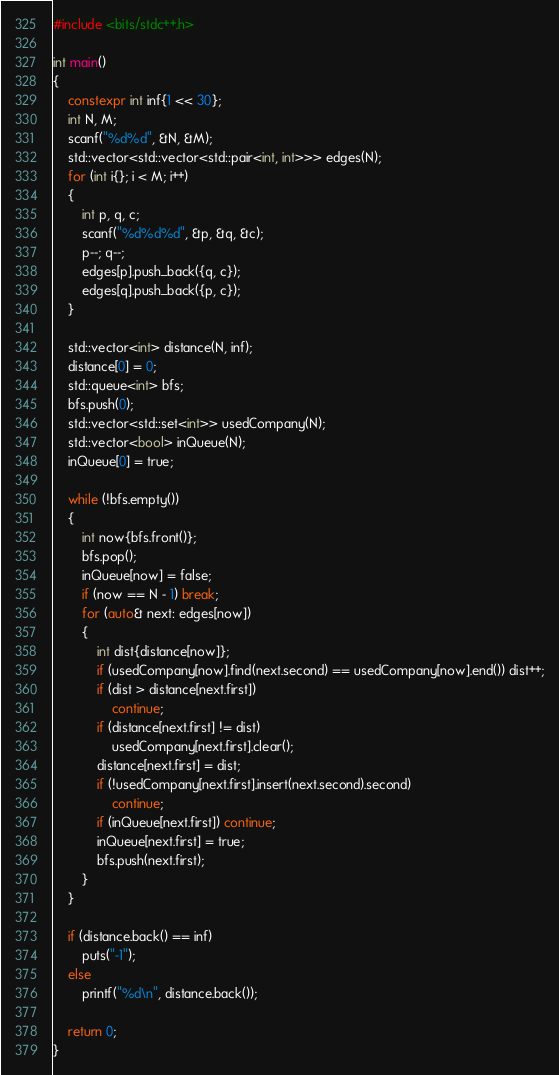Convert code to text. <code><loc_0><loc_0><loc_500><loc_500><_C++_>#include <bits/stdc++.h>

int main()
{
	constexpr int inf{1 << 30};
	int N, M;
	scanf("%d%d", &N, &M);
	std::vector<std::vector<std::pair<int, int>>> edges(N);
	for (int i{}; i < M; i++)
	{
		int p, q, c;
		scanf("%d%d%d", &p, &q, &c);
		p--; q--;
		edges[p].push_back({q, c});
		edges[q].push_back({p, c});
	}

	std::vector<int> distance(N, inf);
	distance[0] = 0;
	std::queue<int> bfs;
	bfs.push(0);
	std::vector<std::set<int>> usedCompany(N);
	std::vector<bool> inQueue(N);
	inQueue[0] = true;

	while (!bfs.empty())
	{
		int now{bfs.front()};
		bfs.pop();
		inQueue[now] = false;
		if (now == N - 1) break;
		for (auto& next: edges[now])
		{
			int dist{distance[now]};
			if (usedCompany[now].find(next.second) == usedCompany[now].end()) dist++;
			if (dist > distance[next.first])
				continue;
			if (distance[next.first] != dist)
				usedCompany[next.first].clear();
			distance[next.first] = dist;
			if (!usedCompany[next.first].insert(next.second).second)
				continue;
			if (inQueue[next.first]) continue;
			inQueue[next.first] = true;
			bfs.push(next.first);
		}
	}

	if (distance.back() == inf)
		puts("-1");
	else
		printf("%d\n", distance.back());

	return 0;
}
</code> 